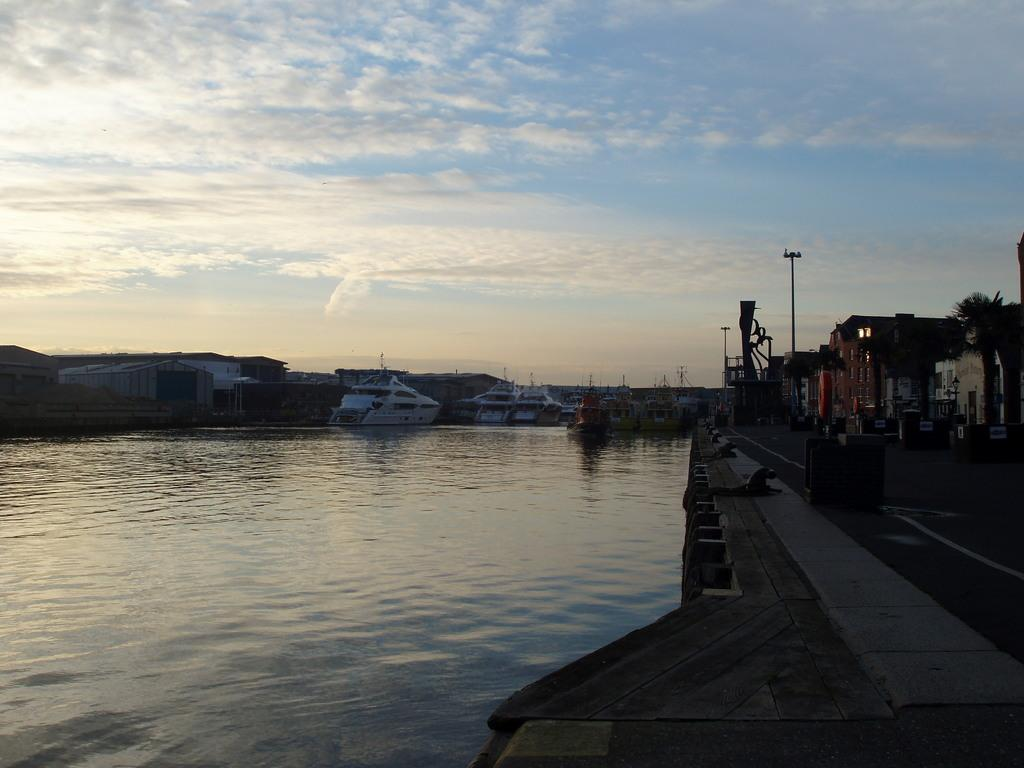What is on the water in the image? There are boats on the water in the image. What structures can be seen in the image? There are buildings in the image. What type of path is present in the image? There is a road in the image. What can be seen in the background of the image? The sky with clouds is visible in the background of the image. Where is the frog hopping in the image? There is no frog present in the image. What type of railway is visible in the image? There is no railway present in the image. 